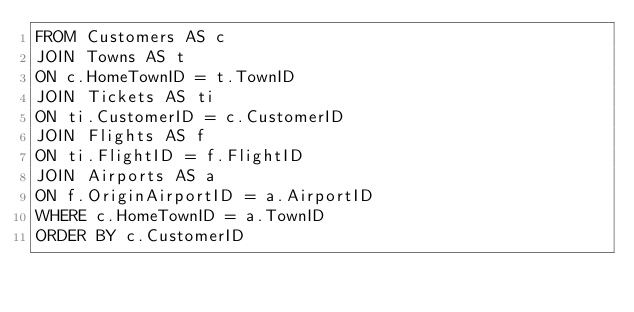Convert code to text. <code><loc_0><loc_0><loc_500><loc_500><_SQL_>FROM Customers AS c
JOIN Towns AS t
ON c.HomeTownID = t.TownID
JOIN Tickets AS ti
ON ti.CustomerID = c.CustomerID
JOIN Flights AS f 
ON ti.FlightID = f.FlightID
JOIN Airports AS a
ON f.OriginAirportID = a.AirportID
WHERE c.HomeTownID = a.TownID
ORDER BY c.CustomerID</code> 